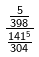<formula> <loc_0><loc_0><loc_500><loc_500>\frac { \frac { 5 } { 3 9 8 } } { \frac { 1 4 1 ^ { 5 } } { 3 0 4 } }</formula> 